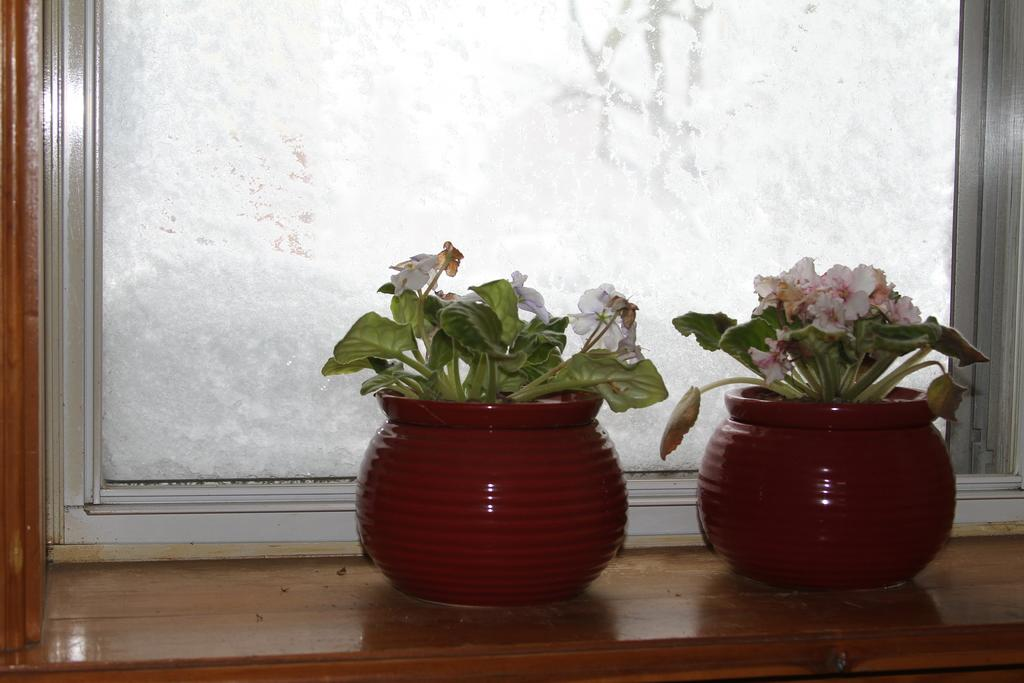What type of plants are in the image? There are plants in pots in the image. What additional features can be seen on the plants? There are flowers in the image. What is the color of the surface on which the pots are placed? The pots are on a brown color surface. What can be seen in the background of the image? There is a window visible in the background of the image. What type of afterthought can be seen in the image? There is no afterthought present in the image; it features plants in pots with flowers, a brown surface, and a window in the background. 